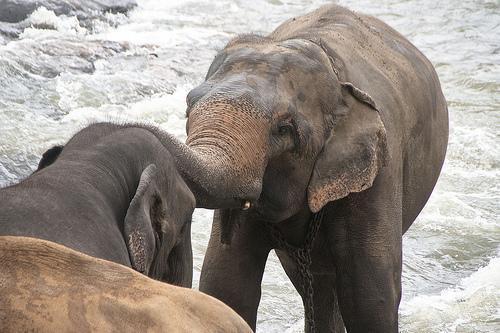How many elephants are there?
Give a very brief answer. 3. 